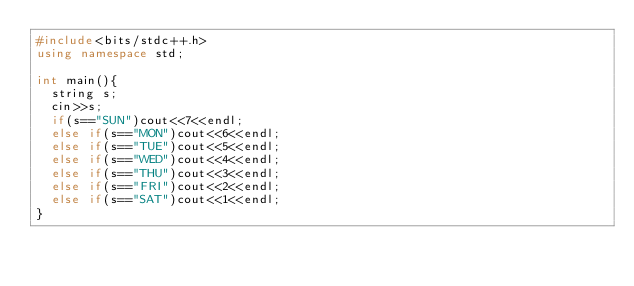Convert code to text. <code><loc_0><loc_0><loc_500><loc_500><_C++_>#include<bits/stdc++.h>
using namespace std;

int main(){
  string s;
  cin>>s;
  if(s=="SUN")cout<<7<<endl;
  else if(s=="MON")cout<<6<<endl;
  else if(s=="TUE")cout<<5<<endl;
  else if(s=="WED")cout<<4<<endl;
  else if(s=="THU")cout<<3<<endl;
  else if(s=="FRI")cout<<2<<endl;
  else if(s=="SAT")cout<<1<<endl;
}</code> 